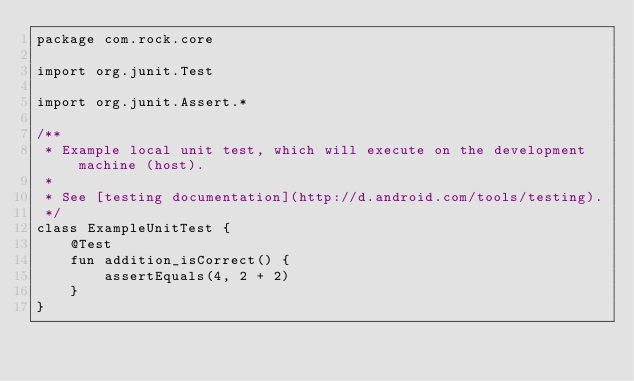Convert code to text. <code><loc_0><loc_0><loc_500><loc_500><_Kotlin_>package com.rock.core

import org.junit.Test

import org.junit.Assert.*

/**
 * Example local unit test, which will execute on the development machine (host).
 *
 * See [testing documentation](http://d.android.com/tools/testing).
 */
class ExampleUnitTest {
    @Test
    fun addition_isCorrect() {
        assertEquals(4, 2 + 2)
    }
}</code> 